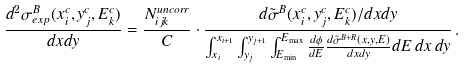<formula> <loc_0><loc_0><loc_500><loc_500>\frac { d ^ { 2 } \sigma ^ { B } _ { e x p } ( x ^ { c } _ { i } , y ^ { c } _ { j } , E ^ { c } _ { k } ) } { d x d y } = \frac { N _ { i j k } ^ { u n c o r r } } { C } \cdot \frac { d \tilde { \sigma } ^ { B } ( x ^ { c } _ { i } , y ^ { c } _ { j } , E ^ { c } _ { k } ) / d x d y } { \int _ { x _ { i } } ^ { x _ { i + 1 } } \int _ { y _ { j } } ^ { y _ { j + 1 } } \int _ { E _ { \min } } ^ { E _ { \max } } \frac { d \phi } { d E } \frac { d \tilde { \sigma } ^ { B + R } ( x , y , E ) } { d x d y } d E \, d x \, d y } \, .</formula> 